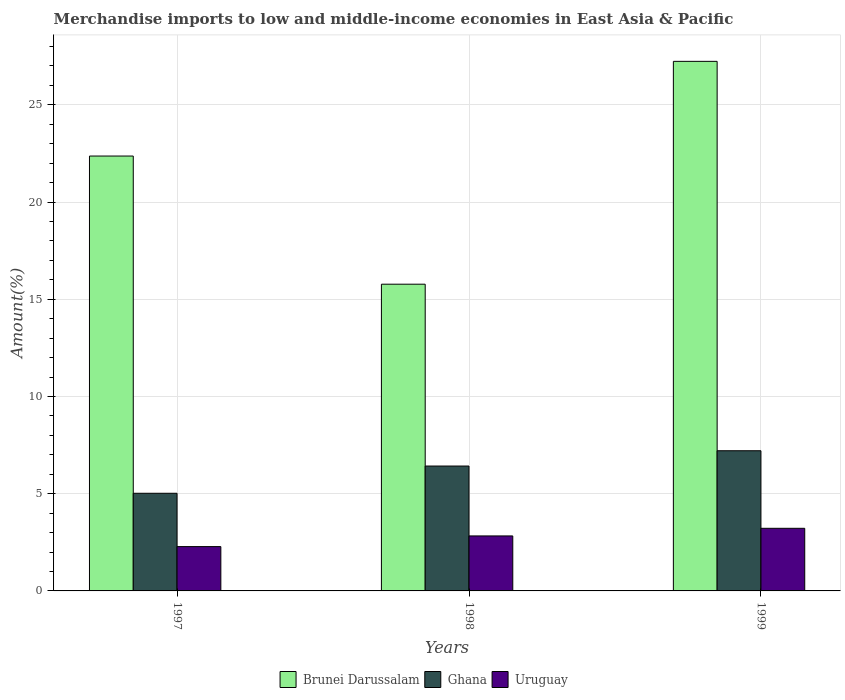How many different coloured bars are there?
Your answer should be very brief. 3. How many groups of bars are there?
Your answer should be very brief. 3. Are the number of bars per tick equal to the number of legend labels?
Keep it short and to the point. Yes. How many bars are there on the 3rd tick from the right?
Keep it short and to the point. 3. What is the label of the 2nd group of bars from the left?
Your answer should be very brief. 1998. What is the percentage of amount earned from merchandise imports in Ghana in 1999?
Keep it short and to the point. 7.21. Across all years, what is the maximum percentage of amount earned from merchandise imports in Brunei Darussalam?
Offer a very short reply. 27.24. Across all years, what is the minimum percentage of amount earned from merchandise imports in Ghana?
Provide a short and direct response. 5.02. What is the total percentage of amount earned from merchandise imports in Ghana in the graph?
Provide a succinct answer. 18.66. What is the difference between the percentage of amount earned from merchandise imports in Brunei Darussalam in 1997 and that in 1998?
Provide a short and direct response. 6.59. What is the difference between the percentage of amount earned from merchandise imports in Brunei Darussalam in 1998 and the percentage of amount earned from merchandise imports in Ghana in 1997?
Your answer should be very brief. 10.75. What is the average percentage of amount earned from merchandise imports in Ghana per year?
Provide a short and direct response. 6.22. In the year 1999, what is the difference between the percentage of amount earned from merchandise imports in Brunei Darussalam and percentage of amount earned from merchandise imports in Ghana?
Offer a very short reply. 20.03. In how many years, is the percentage of amount earned from merchandise imports in Ghana greater than 12 %?
Ensure brevity in your answer.  0. What is the ratio of the percentage of amount earned from merchandise imports in Uruguay in 1998 to that in 1999?
Give a very brief answer. 0.88. Is the percentage of amount earned from merchandise imports in Brunei Darussalam in 1998 less than that in 1999?
Offer a very short reply. Yes. What is the difference between the highest and the second highest percentage of amount earned from merchandise imports in Ghana?
Ensure brevity in your answer.  0.79. What is the difference between the highest and the lowest percentage of amount earned from merchandise imports in Brunei Darussalam?
Your answer should be very brief. 11.46. What does the 3rd bar from the left in 1997 represents?
Offer a terse response. Uruguay. What does the 3rd bar from the right in 1997 represents?
Provide a succinct answer. Brunei Darussalam. Is it the case that in every year, the sum of the percentage of amount earned from merchandise imports in Brunei Darussalam and percentage of amount earned from merchandise imports in Uruguay is greater than the percentage of amount earned from merchandise imports in Ghana?
Your answer should be compact. Yes. What is the title of the graph?
Ensure brevity in your answer.  Merchandise imports to low and middle-income economies in East Asia & Pacific. Does "Virgin Islands" appear as one of the legend labels in the graph?
Provide a succinct answer. No. What is the label or title of the X-axis?
Provide a succinct answer. Years. What is the label or title of the Y-axis?
Provide a short and direct response. Amount(%). What is the Amount(%) in Brunei Darussalam in 1997?
Provide a succinct answer. 22.37. What is the Amount(%) of Ghana in 1997?
Give a very brief answer. 5.02. What is the Amount(%) of Uruguay in 1997?
Offer a terse response. 2.28. What is the Amount(%) of Brunei Darussalam in 1998?
Your answer should be compact. 15.78. What is the Amount(%) in Ghana in 1998?
Keep it short and to the point. 6.42. What is the Amount(%) of Uruguay in 1998?
Your answer should be compact. 2.83. What is the Amount(%) of Brunei Darussalam in 1999?
Your response must be concise. 27.24. What is the Amount(%) of Ghana in 1999?
Provide a short and direct response. 7.21. What is the Amount(%) of Uruguay in 1999?
Keep it short and to the point. 3.22. Across all years, what is the maximum Amount(%) of Brunei Darussalam?
Your response must be concise. 27.24. Across all years, what is the maximum Amount(%) of Ghana?
Ensure brevity in your answer.  7.21. Across all years, what is the maximum Amount(%) in Uruguay?
Provide a succinct answer. 3.22. Across all years, what is the minimum Amount(%) of Brunei Darussalam?
Make the answer very short. 15.78. Across all years, what is the minimum Amount(%) in Ghana?
Offer a terse response. 5.02. Across all years, what is the minimum Amount(%) of Uruguay?
Make the answer very short. 2.28. What is the total Amount(%) in Brunei Darussalam in the graph?
Give a very brief answer. 65.38. What is the total Amount(%) in Ghana in the graph?
Ensure brevity in your answer.  18.66. What is the total Amount(%) of Uruguay in the graph?
Ensure brevity in your answer.  8.33. What is the difference between the Amount(%) in Brunei Darussalam in 1997 and that in 1998?
Keep it short and to the point. 6.59. What is the difference between the Amount(%) of Ghana in 1997 and that in 1998?
Your answer should be compact. -1.4. What is the difference between the Amount(%) of Uruguay in 1997 and that in 1998?
Offer a terse response. -0.55. What is the difference between the Amount(%) in Brunei Darussalam in 1997 and that in 1999?
Give a very brief answer. -4.87. What is the difference between the Amount(%) of Ghana in 1997 and that in 1999?
Provide a succinct answer. -2.19. What is the difference between the Amount(%) of Uruguay in 1997 and that in 1999?
Offer a terse response. -0.94. What is the difference between the Amount(%) in Brunei Darussalam in 1998 and that in 1999?
Offer a terse response. -11.46. What is the difference between the Amount(%) in Ghana in 1998 and that in 1999?
Offer a terse response. -0.79. What is the difference between the Amount(%) in Uruguay in 1998 and that in 1999?
Provide a short and direct response. -0.39. What is the difference between the Amount(%) of Brunei Darussalam in 1997 and the Amount(%) of Ghana in 1998?
Make the answer very short. 15.94. What is the difference between the Amount(%) in Brunei Darussalam in 1997 and the Amount(%) in Uruguay in 1998?
Make the answer very short. 19.54. What is the difference between the Amount(%) of Ghana in 1997 and the Amount(%) of Uruguay in 1998?
Make the answer very short. 2.19. What is the difference between the Amount(%) in Brunei Darussalam in 1997 and the Amount(%) in Ghana in 1999?
Ensure brevity in your answer.  15.16. What is the difference between the Amount(%) of Brunei Darussalam in 1997 and the Amount(%) of Uruguay in 1999?
Provide a succinct answer. 19.15. What is the difference between the Amount(%) in Ghana in 1997 and the Amount(%) in Uruguay in 1999?
Provide a short and direct response. 1.8. What is the difference between the Amount(%) of Brunei Darussalam in 1998 and the Amount(%) of Ghana in 1999?
Make the answer very short. 8.57. What is the difference between the Amount(%) of Brunei Darussalam in 1998 and the Amount(%) of Uruguay in 1999?
Provide a succinct answer. 12.56. What is the difference between the Amount(%) in Ghana in 1998 and the Amount(%) in Uruguay in 1999?
Ensure brevity in your answer.  3.2. What is the average Amount(%) of Brunei Darussalam per year?
Your answer should be very brief. 21.79. What is the average Amount(%) of Ghana per year?
Provide a succinct answer. 6.22. What is the average Amount(%) of Uruguay per year?
Offer a very short reply. 2.78. In the year 1997, what is the difference between the Amount(%) in Brunei Darussalam and Amount(%) in Ghana?
Give a very brief answer. 17.35. In the year 1997, what is the difference between the Amount(%) of Brunei Darussalam and Amount(%) of Uruguay?
Give a very brief answer. 20.09. In the year 1997, what is the difference between the Amount(%) in Ghana and Amount(%) in Uruguay?
Ensure brevity in your answer.  2.74. In the year 1998, what is the difference between the Amount(%) in Brunei Darussalam and Amount(%) in Ghana?
Your answer should be very brief. 9.35. In the year 1998, what is the difference between the Amount(%) of Brunei Darussalam and Amount(%) of Uruguay?
Your answer should be very brief. 12.95. In the year 1998, what is the difference between the Amount(%) in Ghana and Amount(%) in Uruguay?
Ensure brevity in your answer.  3.59. In the year 1999, what is the difference between the Amount(%) in Brunei Darussalam and Amount(%) in Ghana?
Ensure brevity in your answer.  20.03. In the year 1999, what is the difference between the Amount(%) of Brunei Darussalam and Amount(%) of Uruguay?
Keep it short and to the point. 24.02. In the year 1999, what is the difference between the Amount(%) of Ghana and Amount(%) of Uruguay?
Your answer should be compact. 3.99. What is the ratio of the Amount(%) of Brunei Darussalam in 1997 to that in 1998?
Keep it short and to the point. 1.42. What is the ratio of the Amount(%) in Ghana in 1997 to that in 1998?
Offer a very short reply. 0.78. What is the ratio of the Amount(%) of Uruguay in 1997 to that in 1998?
Offer a terse response. 0.81. What is the ratio of the Amount(%) in Brunei Darussalam in 1997 to that in 1999?
Provide a short and direct response. 0.82. What is the ratio of the Amount(%) of Ghana in 1997 to that in 1999?
Provide a short and direct response. 0.7. What is the ratio of the Amount(%) in Uruguay in 1997 to that in 1999?
Provide a short and direct response. 0.71. What is the ratio of the Amount(%) of Brunei Darussalam in 1998 to that in 1999?
Provide a short and direct response. 0.58. What is the ratio of the Amount(%) of Ghana in 1998 to that in 1999?
Give a very brief answer. 0.89. What is the ratio of the Amount(%) of Uruguay in 1998 to that in 1999?
Your answer should be compact. 0.88. What is the difference between the highest and the second highest Amount(%) in Brunei Darussalam?
Keep it short and to the point. 4.87. What is the difference between the highest and the second highest Amount(%) of Ghana?
Offer a terse response. 0.79. What is the difference between the highest and the second highest Amount(%) in Uruguay?
Provide a short and direct response. 0.39. What is the difference between the highest and the lowest Amount(%) of Brunei Darussalam?
Keep it short and to the point. 11.46. What is the difference between the highest and the lowest Amount(%) in Ghana?
Your answer should be compact. 2.19. What is the difference between the highest and the lowest Amount(%) of Uruguay?
Keep it short and to the point. 0.94. 